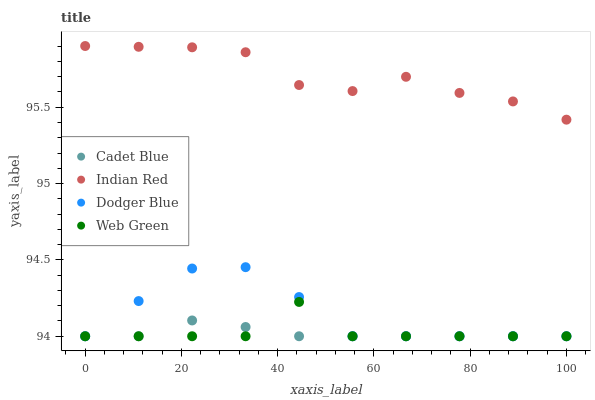Does Cadet Blue have the minimum area under the curve?
Answer yes or no. Yes. Does Indian Red have the maximum area under the curve?
Answer yes or no. Yes. Does Dodger Blue have the minimum area under the curve?
Answer yes or no. No. Does Dodger Blue have the maximum area under the curve?
Answer yes or no. No. Is Cadet Blue the smoothest?
Answer yes or no. Yes. Is Web Green the roughest?
Answer yes or no. Yes. Is Dodger Blue the smoothest?
Answer yes or no. No. Is Dodger Blue the roughest?
Answer yes or no. No. Does Cadet Blue have the lowest value?
Answer yes or no. Yes. Does Indian Red have the lowest value?
Answer yes or no. No. Does Indian Red have the highest value?
Answer yes or no. Yes. Does Dodger Blue have the highest value?
Answer yes or no. No. Is Web Green less than Indian Red?
Answer yes or no. Yes. Is Indian Red greater than Dodger Blue?
Answer yes or no. Yes. Does Dodger Blue intersect Web Green?
Answer yes or no. Yes. Is Dodger Blue less than Web Green?
Answer yes or no. No. Is Dodger Blue greater than Web Green?
Answer yes or no. No. Does Web Green intersect Indian Red?
Answer yes or no. No. 